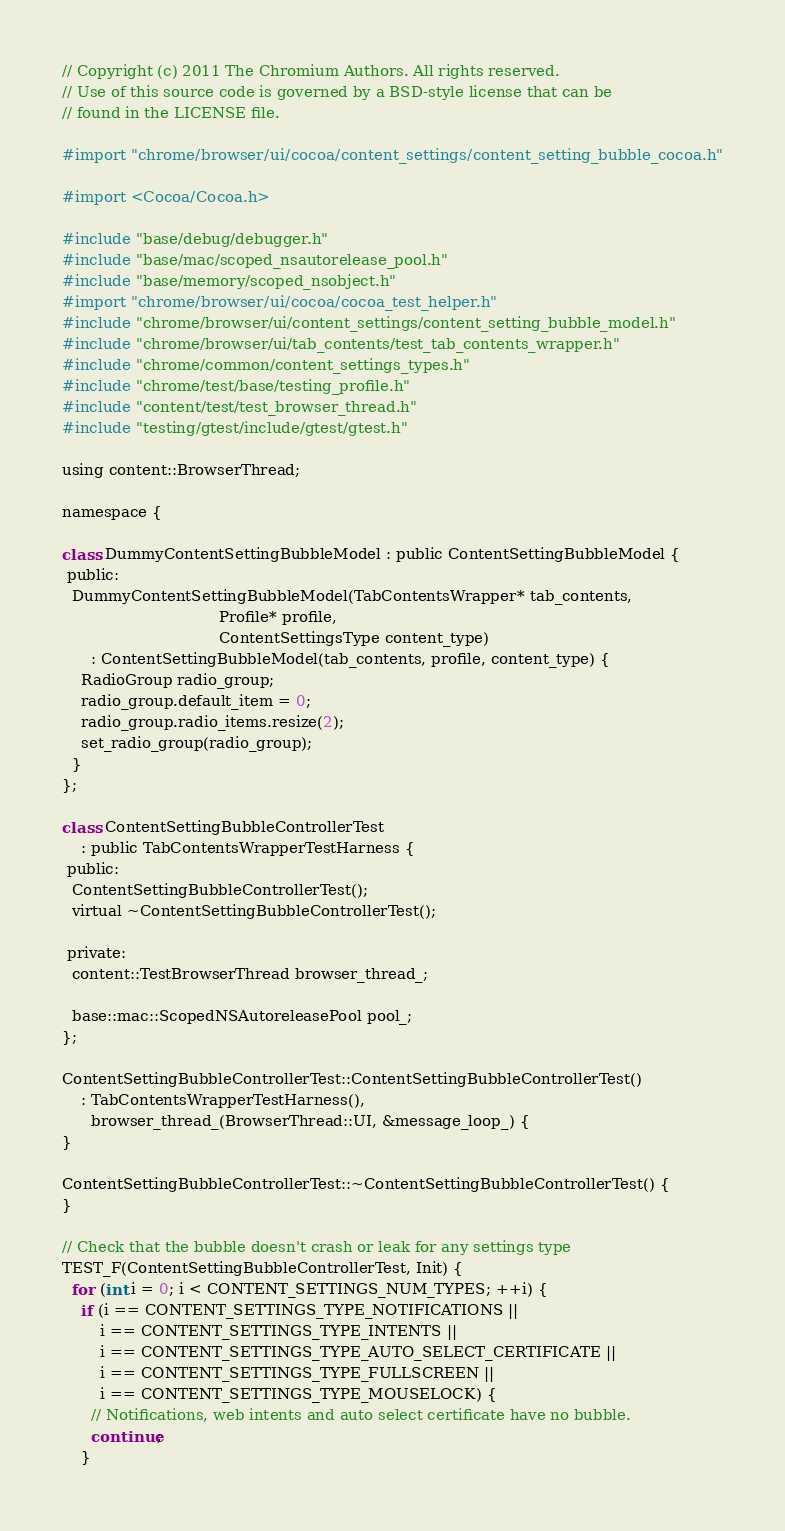<code> <loc_0><loc_0><loc_500><loc_500><_ObjectiveC_>// Copyright (c) 2011 The Chromium Authors. All rights reserved.
// Use of this source code is governed by a BSD-style license that can be
// found in the LICENSE file.

#import "chrome/browser/ui/cocoa/content_settings/content_setting_bubble_cocoa.h"

#import <Cocoa/Cocoa.h>

#include "base/debug/debugger.h"
#include "base/mac/scoped_nsautorelease_pool.h"
#include "base/memory/scoped_nsobject.h"
#import "chrome/browser/ui/cocoa/cocoa_test_helper.h"
#include "chrome/browser/ui/content_settings/content_setting_bubble_model.h"
#include "chrome/browser/ui/tab_contents/test_tab_contents_wrapper.h"
#include "chrome/common/content_settings_types.h"
#include "chrome/test/base/testing_profile.h"
#include "content/test/test_browser_thread.h"
#include "testing/gtest/include/gtest/gtest.h"

using content::BrowserThread;

namespace {

class DummyContentSettingBubbleModel : public ContentSettingBubbleModel {
 public:
  DummyContentSettingBubbleModel(TabContentsWrapper* tab_contents,
                                 Profile* profile,
                                 ContentSettingsType content_type)
      : ContentSettingBubbleModel(tab_contents, profile, content_type) {
    RadioGroup radio_group;
    radio_group.default_item = 0;
    radio_group.radio_items.resize(2);
    set_radio_group(radio_group);
  }
};

class ContentSettingBubbleControllerTest
    : public TabContentsWrapperTestHarness {
 public:
  ContentSettingBubbleControllerTest();
  virtual ~ContentSettingBubbleControllerTest();

 private:
  content::TestBrowserThread browser_thread_;

  base::mac::ScopedNSAutoreleasePool pool_;
};

ContentSettingBubbleControllerTest::ContentSettingBubbleControllerTest()
    : TabContentsWrapperTestHarness(),
      browser_thread_(BrowserThread::UI, &message_loop_) {
}

ContentSettingBubbleControllerTest::~ContentSettingBubbleControllerTest() {
}

// Check that the bubble doesn't crash or leak for any settings type
TEST_F(ContentSettingBubbleControllerTest, Init) {
  for (int i = 0; i < CONTENT_SETTINGS_NUM_TYPES; ++i) {
    if (i == CONTENT_SETTINGS_TYPE_NOTIFICATIONS ||
        i == CONTENT_SETTINGS_TYPE_INTENTS ||
        i == CONTENT_SETTINGS_TYPE_AUTO_SELECT_CERTIFICATE ||
        i == CONTENT_SETTINGS_TYPE_FULLSCREEN ||
        i == CONTENT_SETTINGS_TYPE_MOUSELOCK) {
      // Notifications, web intents and auto select certificate have no bubble.
      continue;
    }
</code> 